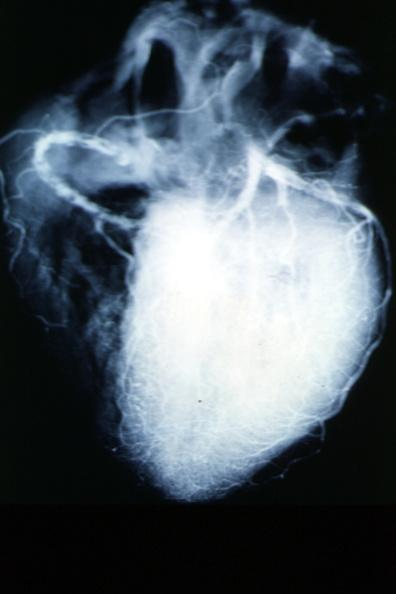how does this image show x-ray postmortcoronary arteries?
Answer the question using a single word or phrase. With multiple lesions 